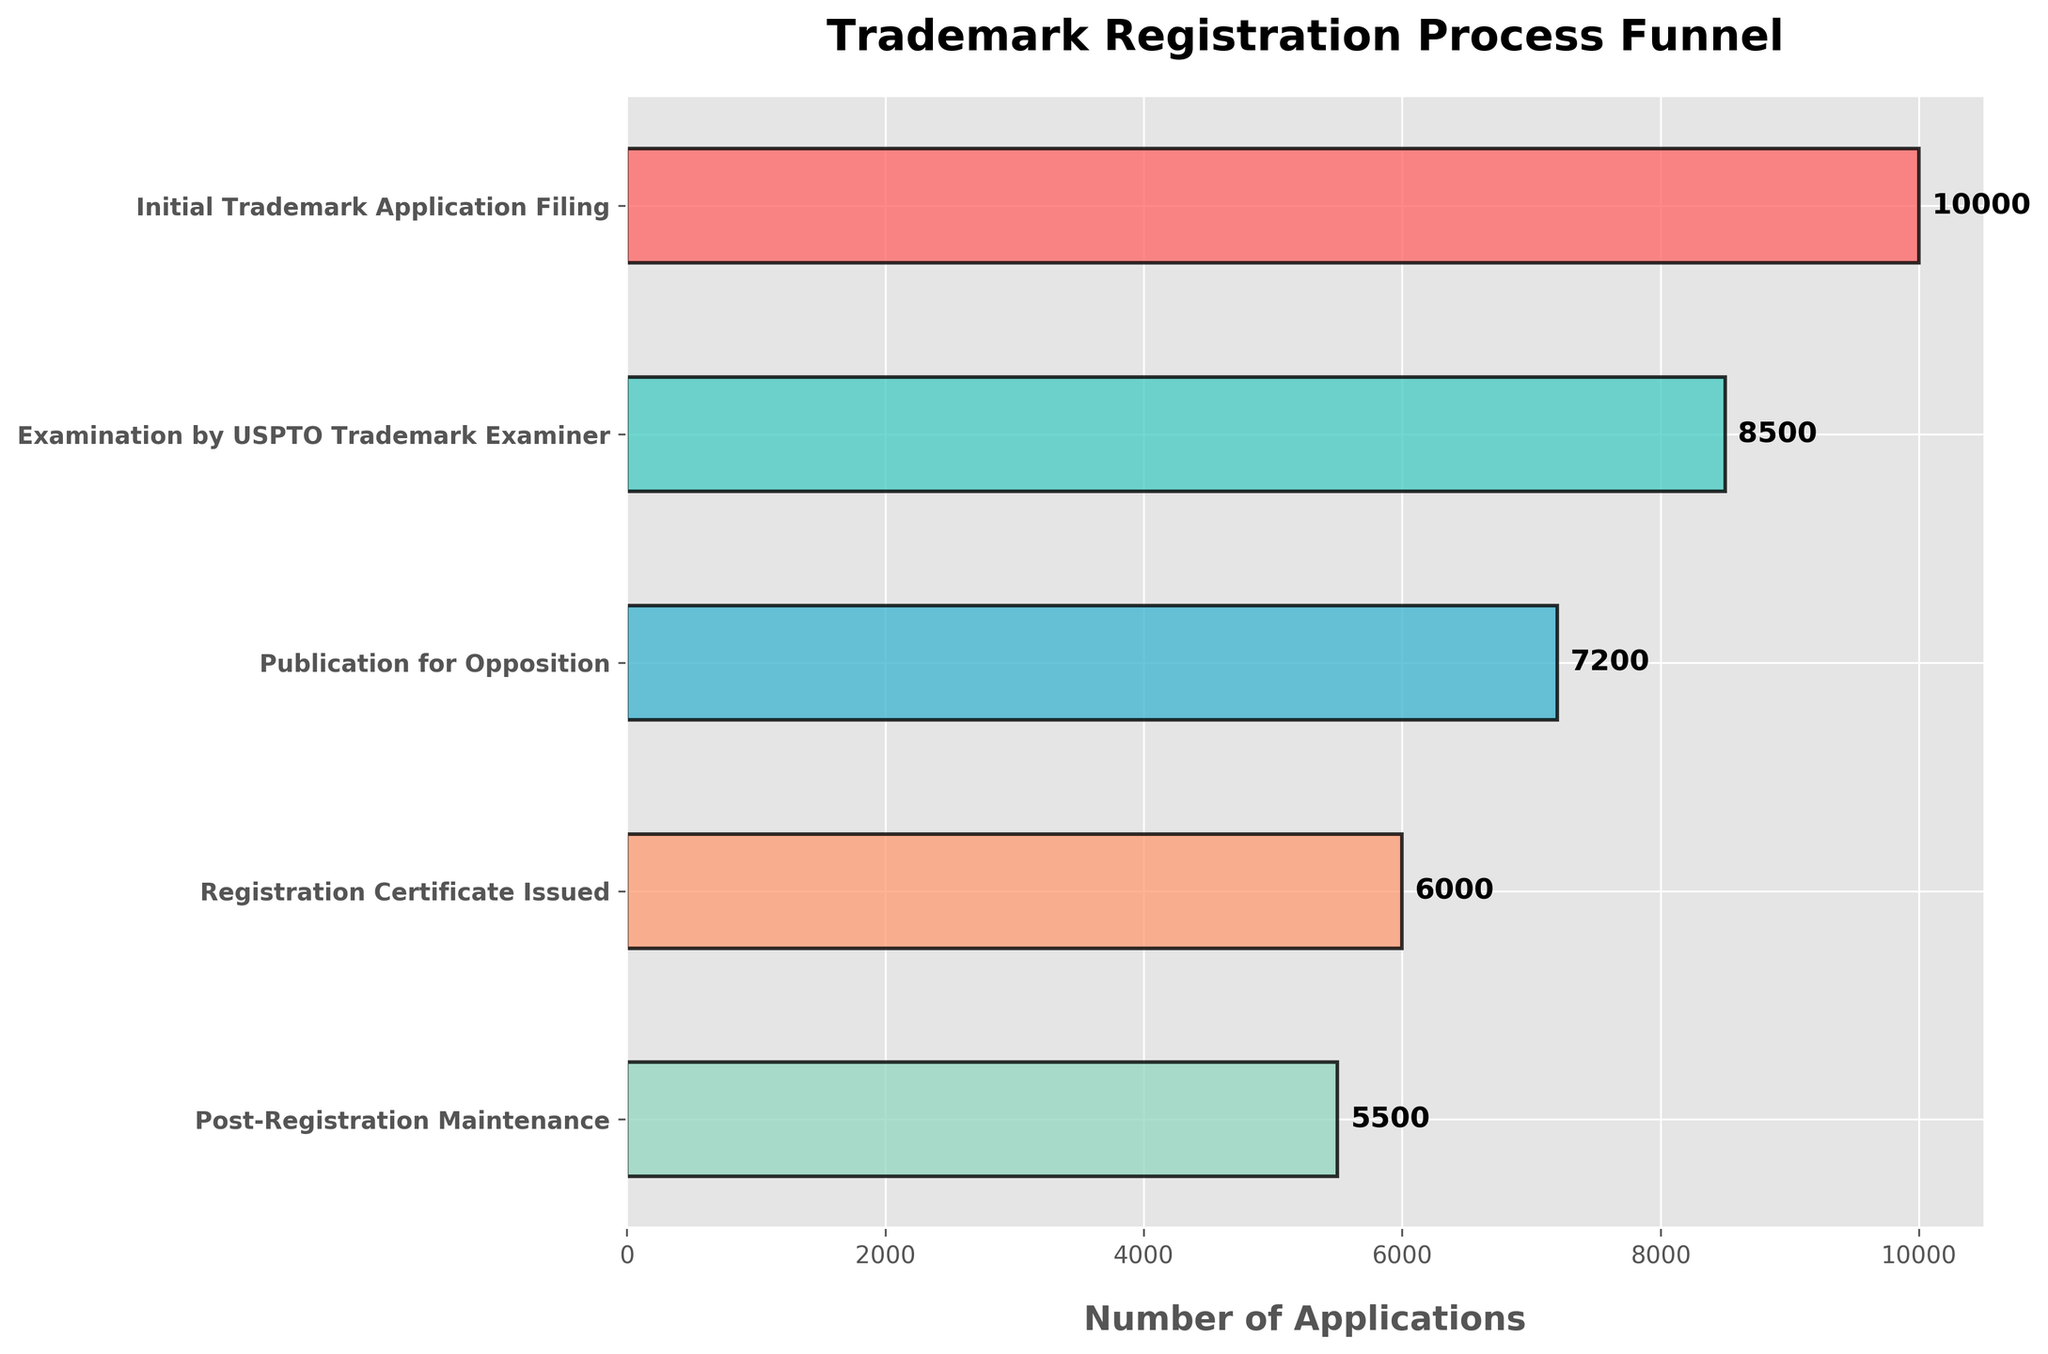What is the title of the chart? The title of the chart is usually found at the top of the figure in a prominent font size. It provides the subject of the chart.
Answer: Trademark Registration Process Funnel How many stages are depicted in the funnel chart? Count the number of distinct horizontal bars representing different stages, each labeled on the left.
Answer: 5 What is the number of applications at the initial stage? Locate the label "Initial Trademark Application Filing" on the left and check the number associated with it on the horizontal bar.
Answer: 10000 Which stage has the smallest number of applications? Compare the numbers for each stage on the horizontal bars. The smallest number indicates the last stage, "Post-Registration Maintenance."
Answer: Post-Registration Maintenance How many applications are lost between the initial filing and examination by the USPTO Trademark Examiner? Subtract the number of applications at "Examination by USPTO Trademark Examiner" from the "Initial Trademark Application Filing." (10000 - 8500)
Answer: 1500 What percentage of applications move from the initial filing to registration certificate issuance? First, find the numbers for "Initial Trademark Application Filing" and "Registration Certificate Issued." Then, calculate the percentage: (6000 / 10000) * 100.
Answer: 60% Compare the stage with the second highest number of applications to the stage with the lowest applications. What is the difference in the number of applications between these two stages? Identify the stage with the second highest number (Examination by USPTO Trademark Examiner: 8500) and the stage with the lowest number (Post-Registration Maintenance: 5500). Subtract the lower number from the higher number: (8500 - 5500).
Answer: 3000 What stage involves the largest drop in the number of applications? Assess each drop between consecutive stages by calculating differences: Initial to Examination (1500), Examination to Publication (1300), Publication to Registration (1200), Registration to Maintenance (500). The largest drop is from Initial to Examination: 1500.
Answer: Examination by USPTO Trademark Examiner What fraction of applications that went through Publication for Opposition make it to receiving the Registration Certificate? Find the numbers for "Publication for Opposition" and "Registration Certificate Issued." Then, calculate the fraction: 6000 / 7200.
Answer: 5/6 or approximately 0.83 Describe the trend in the number of applications from the initial filing to post-registration maintenance. By observing the bar lengths from the top to the bottom (initial to final stage), it is clear that the number of applications decreases progressively at each stage.
Answer: Decreasing 